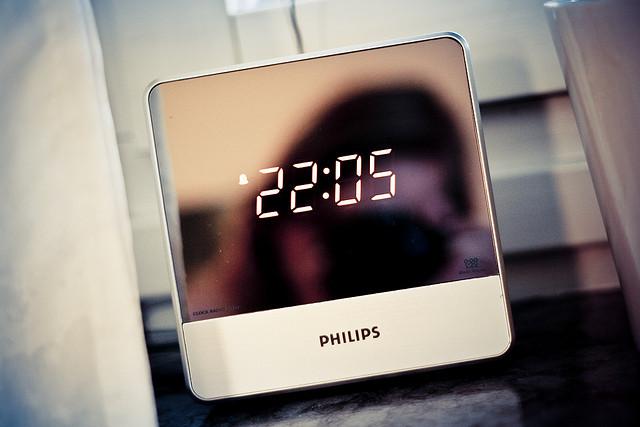What time is displayed on the clock?
Concise answer only. 22:05. Is this an old alarm clock?
Keep it brief. No. What logo can be seen?
Be succinct. Philips. 